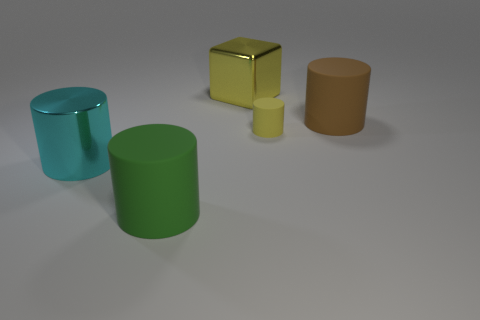Subtract all cyan cylinders. How many cylinders are left? 3 Add 4 small brown metallic objects. How many objects exist? 9 Subtract all blue cylinders. Subtract all cyan spheres. How many cylinders are left? 4 Subtract all cylinders. How many objects are left? 1 Add 3 tiny blue things. How many tiny blue things exist? 3 Subtract 1 cyan cylinders. How many objects are left? 4 Subtract all cyan metal cylinders. Subtract all cyan shiny cylinders. How many objects are left? 3 Add 1 blocks. How many blocks are left? 2 